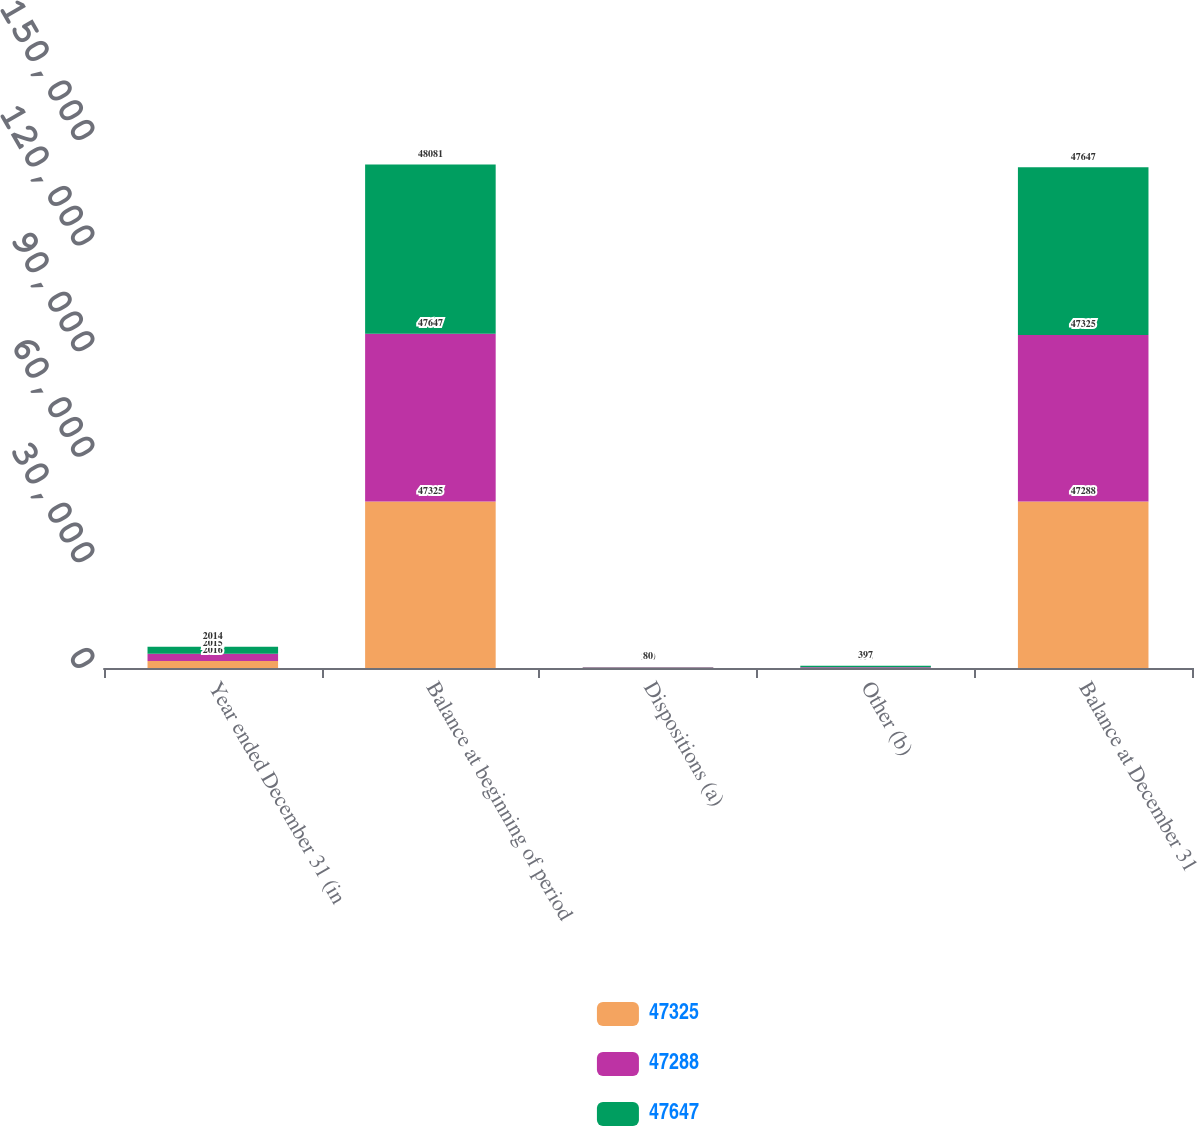Convert chart. <chart><loc_0><loc_0><loc_500><loc_500><stacked_bar_chart><ecel><fcel>Year ended December 31 (in<fcel>Balance at beginning of period<fcel>Dispositions (a)<fcel>Other (b)<fcel>Balance at December 31<nl><fcel>47325<fcel>2016<fcel>47325<fcel>72<fcel>35<fcel>47288<nl><fcel>47288<fcel>2015<fcel>47647<fcel>160<fcel>190<fcel>47325<nl><fcel>47647<fcel>2014<fcel>48081<fcel>80<fcel>397<fcel>47647<nl></chart> 